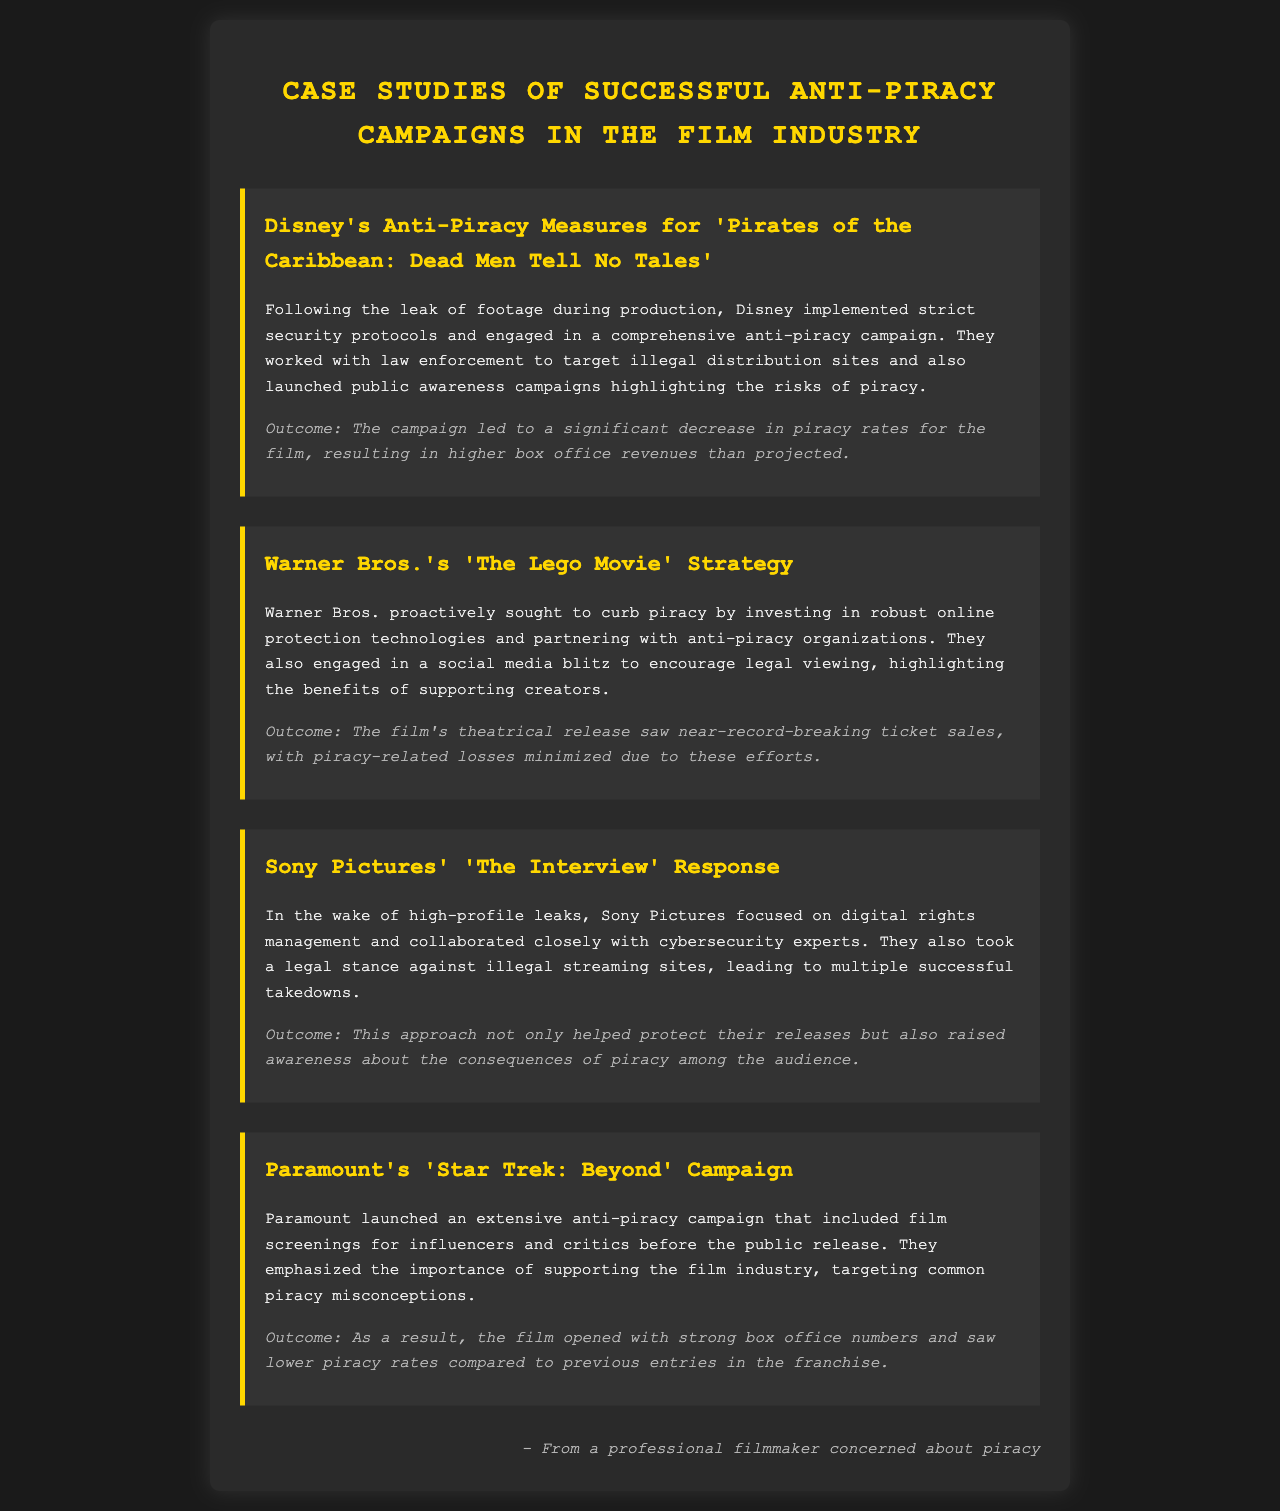What are Disney's anti-piracy measures for 'Pirates of the Caribbean: Dead Men Tell No Tales'? Disney implemented strict security protocols and engaged in a comprehensive anti-piracy campaign, working with law enforcement to target illegal sites and launching public awareness campaigns.
Answer: Strict security protocols What was the outcome of Warner Bros.'s anti-piracy efforts for 'The Lego Movie'? The outcome of the efforts led to near-record-breaking ticket sales, with piracy-related losses minimized due to proactive measures.
Answer: Near-record-breaking ticket sales Which film did Sony Pictures focus on digital rights management and collaborate with cybersecurity experts? The specific film mentioned in the document regarding Sony Pictures' digital rights management and security collaboration is 'The Interview'.
Answer: The Interview What type of campaign did Paramount launch for 'Star Trek: Beyond'? Paramount launched an extensive anti-piracy campaign that included film screenings for influencers and critics to raise awareness about supporting the film industry.
Answer: Extensive anti-piracy campaign What was a significant action take by Warner Bros. against piracy? Warner Bros. invested in robust online protection technologies and partnered with anti-piracy organizations as significant actions against piracy.
Answer: Robust online protection technologies How did Disney's anti-piracy campaign impact box office revenues? The campaign resulted in higher box office revenues than projected, indicating its effectiveness against piracy.
Answer: Higher box office revenues What is a common goal shared among the anti-piracy campaigns mentioned? A common goal shared among the campaigns is to minimize piracy-related losses and protect box office revenue.
Answer: Minimize piracy-related losses What was a major issue addressed by Sony Pictures in their anti-piracy strategy? A major issue addressed by Sony Pictures was the legal stance against illegal streaming sites, leading to multiple successful takedowns.
Answer: Legal stance against illegal streaming sites What strategy did Paramount emphasize in their anti-piracy campaign? Paramount emphasized the importance of supporting the film industry and targeted common piracy misconceptions in their campaign.
Answer: Importance of supporting the film industry 